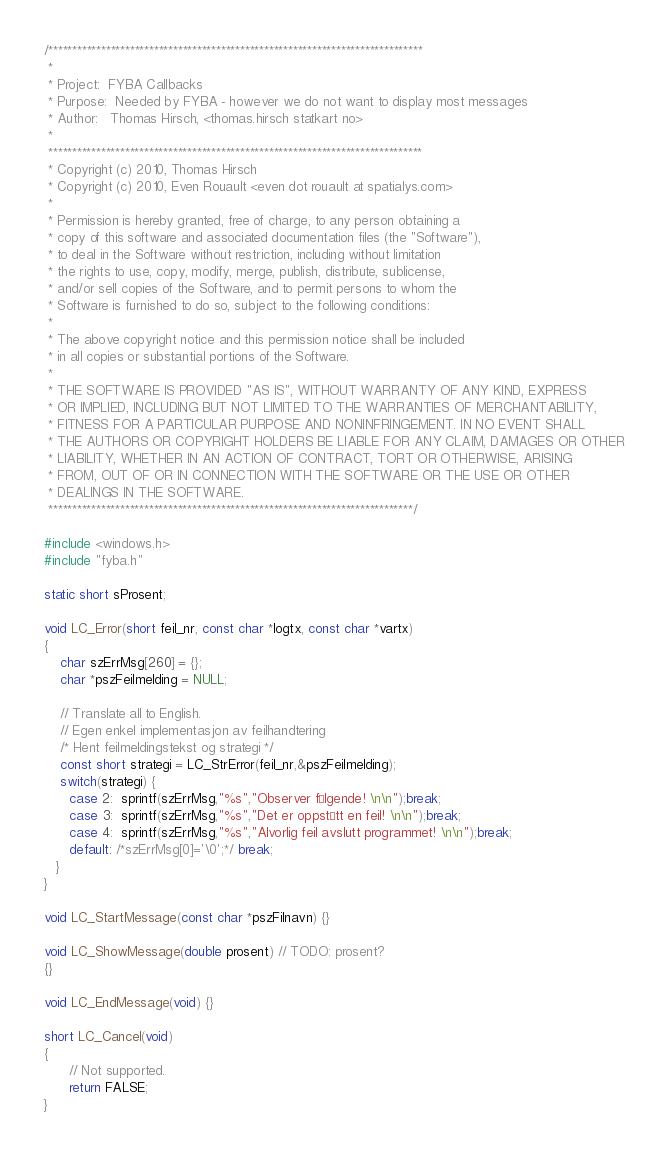<code> <loc_0><loc_0><loc_500><loc_500><_C++_>/******************************************************************************
 *
 * Project:  FYBA Callbacks
 * Purpose:  Needed by FYBA - however we do not want to display most messages
 * Author:   Thomas Hirsch, <thomas.hirsch statkart no>
 *
 ******************************************************************************
 * Copyright (c) 2010, Thomas Hirsch
 * Copyright (c) 2010, Even Rouault <even dot rouault at spatialys.com>
 *
 * Permission is hereby granted, free of charge, to any person obtaining a
 * copy of this software and associated documentation files (the "Software"),
 * to deal in the Software without restriction, including without limitation
 * the rights to use, copy, modify, merge, publish, distribute, sublicense,
 * and/or sell copies of the Software, and to permit persons to whom the
 * Software is furnished to do so, subject to the following conditions:
 *
 * The above copyright notice and this permission notice shall be included
 * in all copies or substantial portions of the Software.
 *
 * THE SOFTWARE IS PROVIDED "AS IS", WITHOUT WARRANTY OF ANY KIND, EXPRESS
 * OR IMPLIED, INCLUDING BUT NOT LIMITED TO THE WARRANTIES OF MERCHANTABILITY,
 * FITNESS FOR A PARTICULAR PURPOSE AND NONINFRINGEMENT. IN NO EVENT SHALL
 * THE AUTHORS OR COPYRIGHT HOLDERS BE LIABLE FOR ANY CLAIM, DAMAGES OR OTHER
 * LIABILITY, WHETHER IN AN ACTION OF CONTRACT, TORT OR OTHERWISE, ARISING
 * FROM, OUT OF OR IN CONNECTION WITH THE SOFTWARE OR THE USE OR OTHER
 * DEALINGS IN THE SOFTWARE.
 ****************************************************************************/

#include <windows.h>
#include "fyba.h"

static short sProsent;

void LC_Error(short feil_nr, const char *logtx, const char *vartx)
{
    char szErrMsg[260] = {};
    char *pszFeilmelding = NULL;

    // Translate all to English.
    // Egen enkel implementasjon av feilhandtering
    /* Hent feilmeldingstekst og strategi */
    const short strategi = LC_StrError(feil_nr,&pszFeilmelding);
    switch(strategi) {
      case 2:  sprintf(szErrMsg,"%s","Observer følgende! \n\n");break;
      case 3:  sprintf(szErrMsg,"%s","Det er oppstått en feil! \n\n");break;
      case 4:  sprintf(szErrMsg,"%s","Alvorlig feil avslutt programmet! \n\n");break;
      default: /*szErrMsg[0]='\0';*/ break;
   }
}

void LC_StartMessage(const char *pszFilnavn) {}

void LC_ShowMessage(double prosent) // TODO: prosent?
{}

void LC_EndMessage(void) {}

short LC_Cancel(void)
{
      // Not supported.
      return FALSE;
}
</code> 